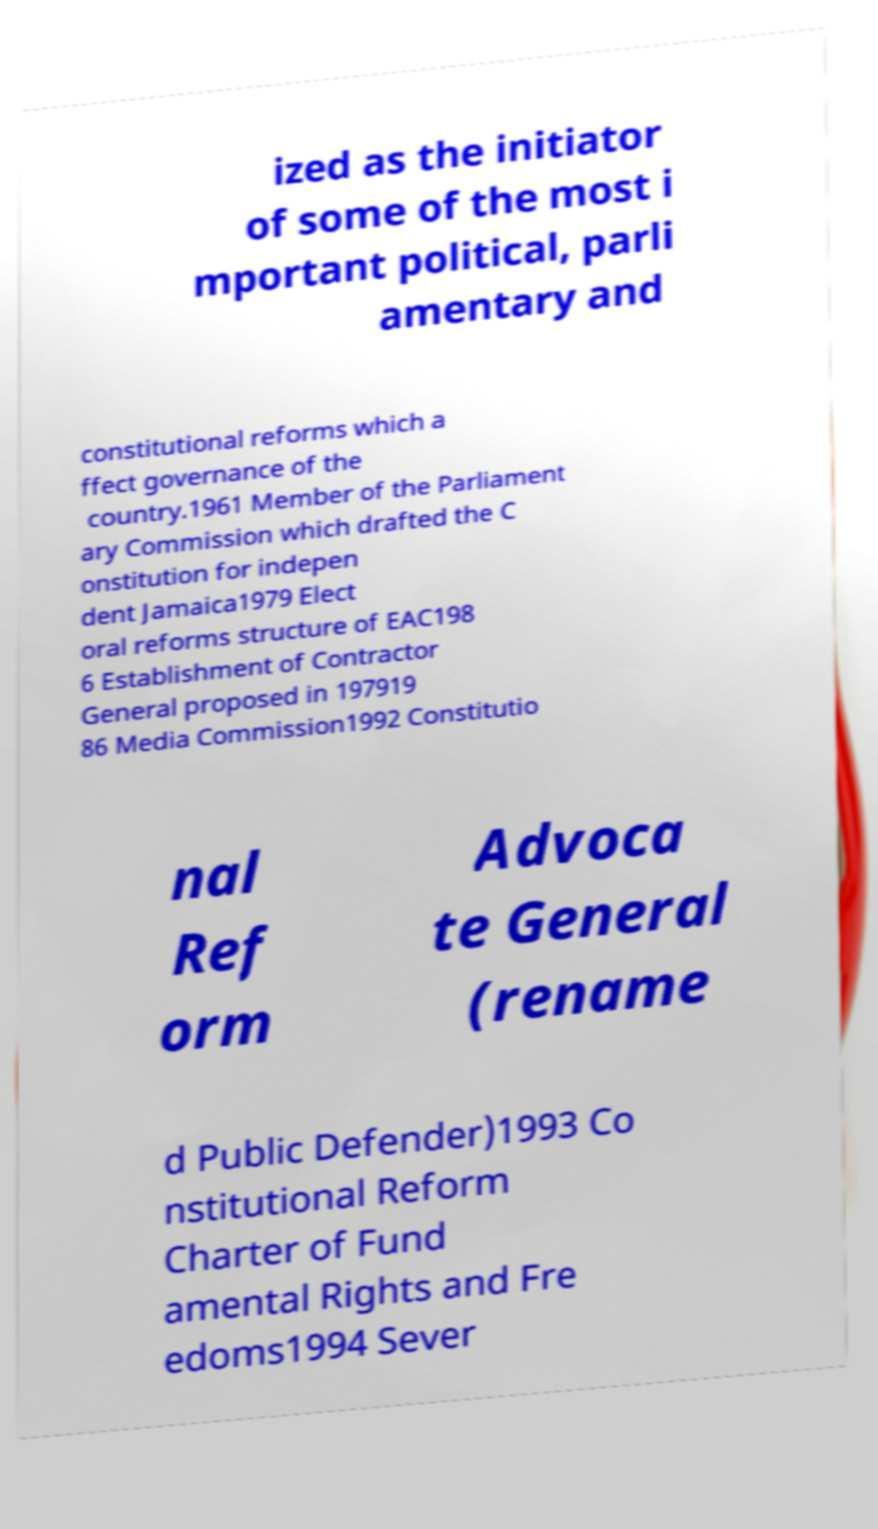Could you extract and type out the text from this image? ized as the initiator of some of the most i mportant political, parli amentary and constitutional reforms which a ffect governance of the country.1961 Member of the Parliament ary Commission which drafted the C onstitution for indepen dent Jamaica1979 Elect oral reforms structure of EAC198 6 Establishment of Contractor General proposed in 197919 86 Media Commission1992 Constitutio nal Ref orm Advoca te General (rename d Public Defender)1993 Co nstitutional Reform Charter of Fund amental Rights and Fre edoms1994 Sever 